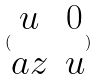Convert formula to latex. <formula><loc_0><loc_0><loc_500><loc_500>( \begin{matrix} u & 0 \\ a z & u \end{matrix} )</formula> 